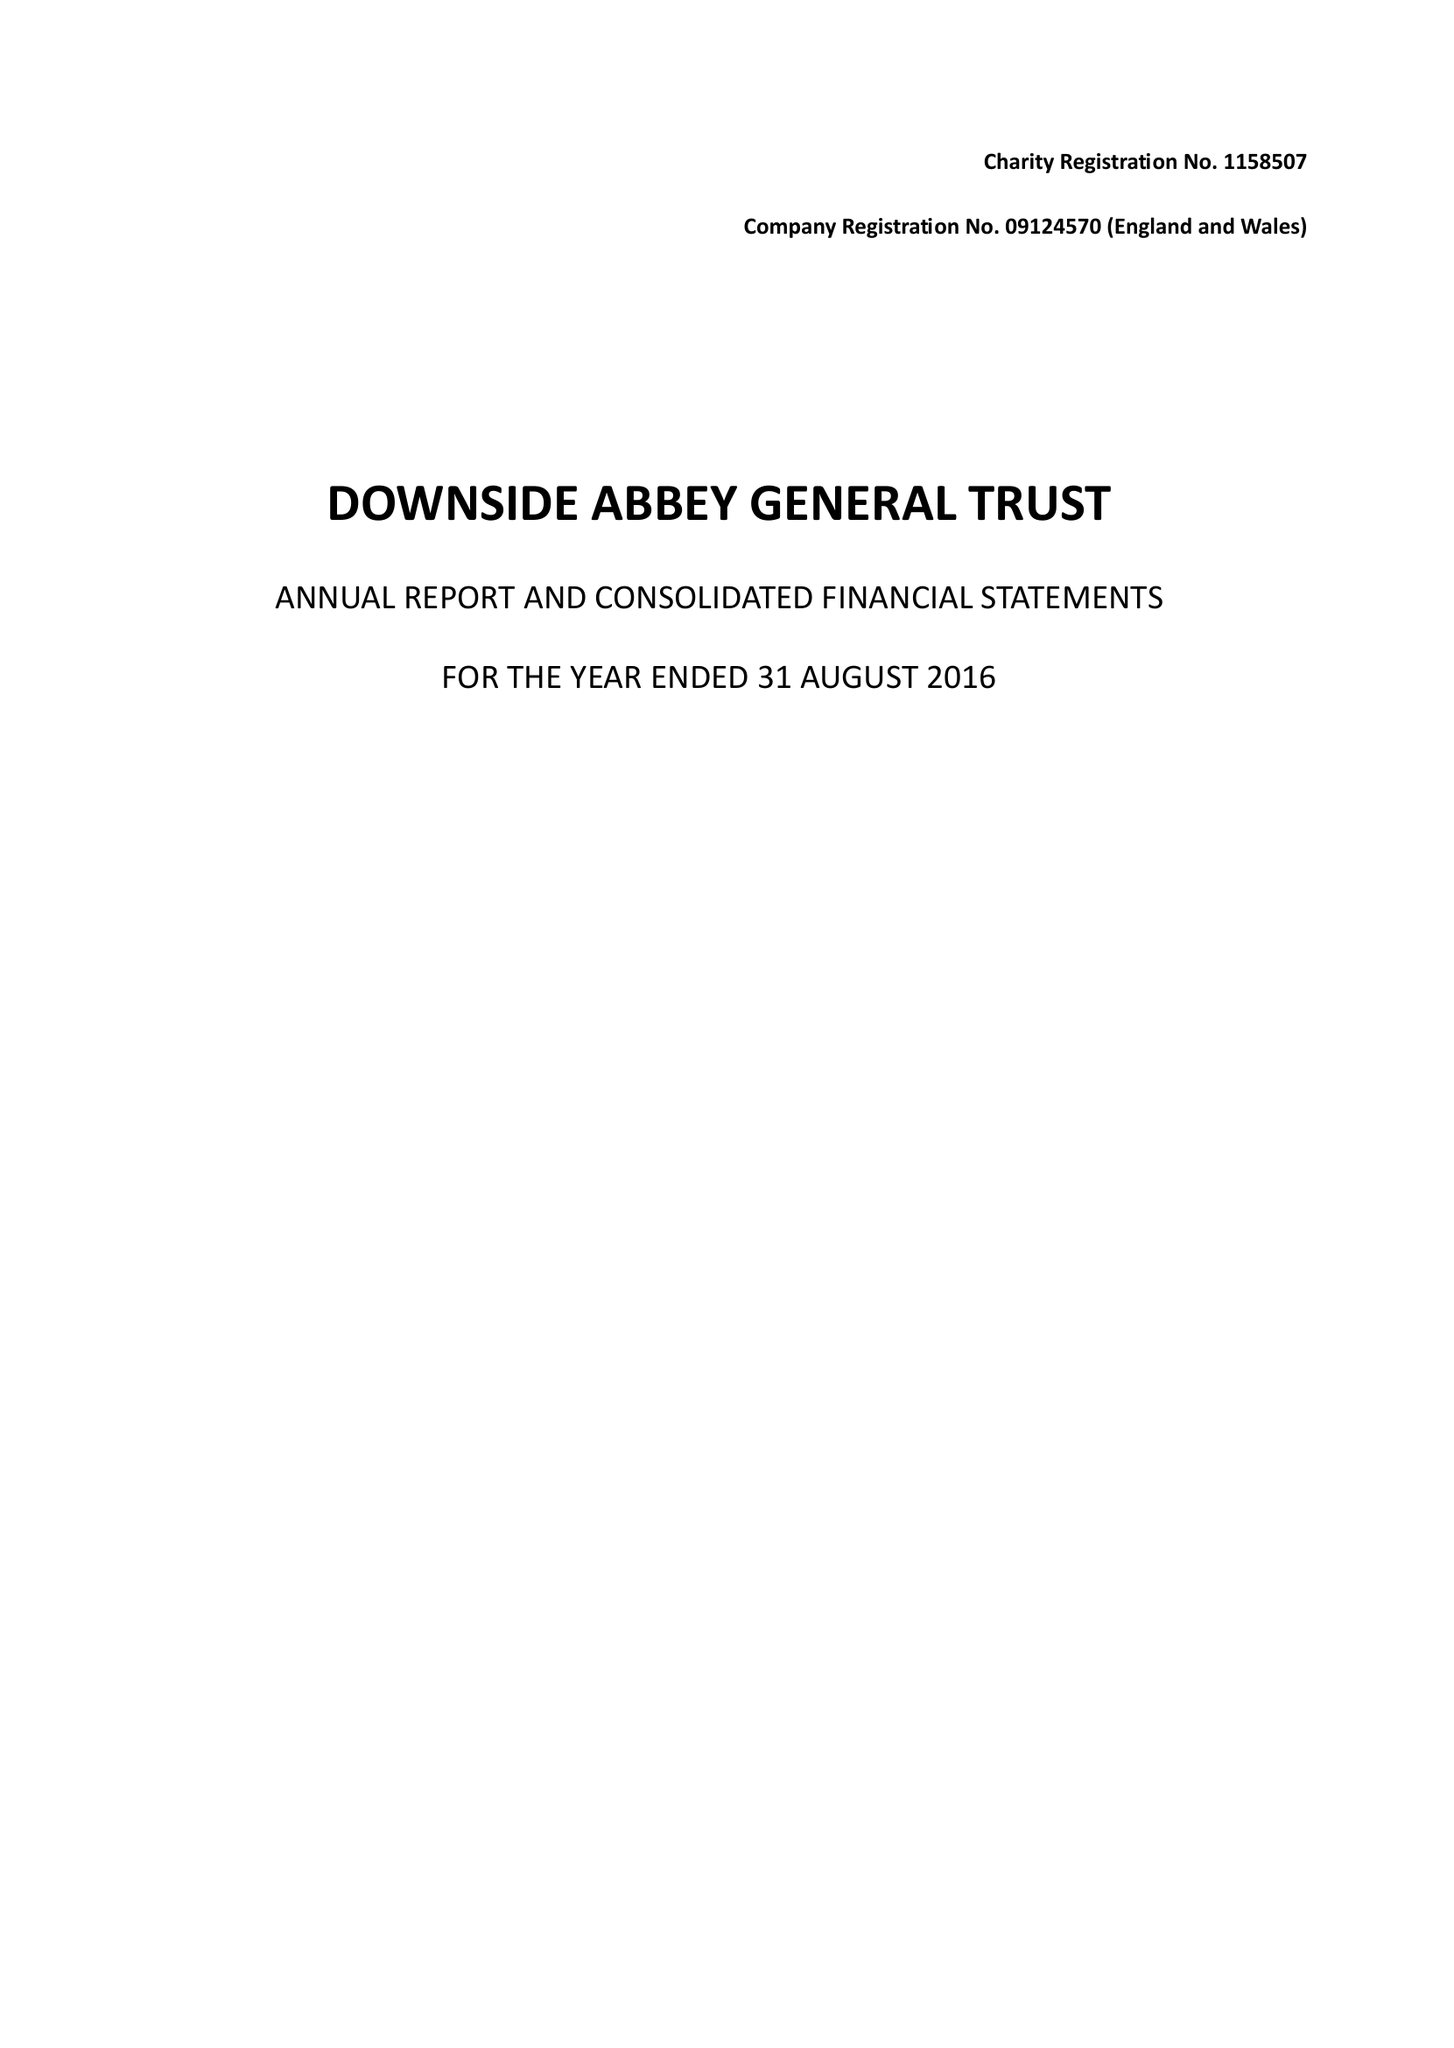What is the value for the address__postcode?
Answer the question using a single word or phrase. BA3 4RH 